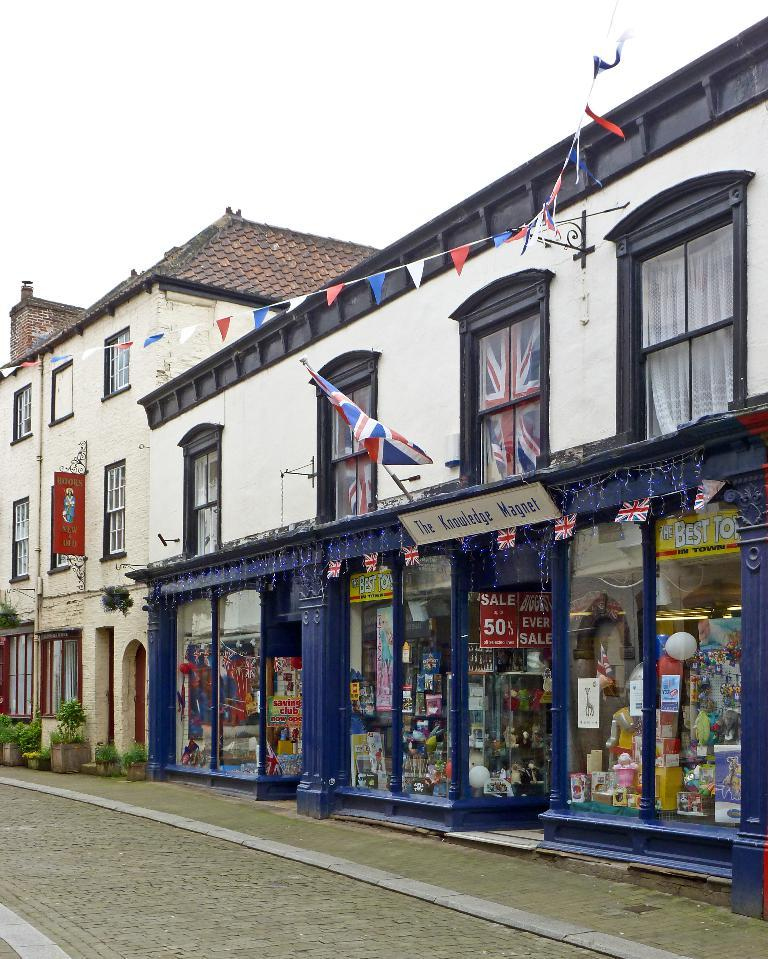What type of structures are located beside the road in the image? There are buildings beside the road in the image. What is one of the buildings used for? One of the buildings houses a store. How can the store be identified in the image? The store has flags displayed. What can be seen inside the store? The store has objects visible. What type of vegetation is present at the bottom left of the image? There are plants at the bottom left of the image. What is visible at the top of the image? The sky is visible at the top of the image. What is the name of the daughter who works at the store in the image? There is no information about a daughter working at the store in the image. How does the light change in the image as time passes? The image is a static representation and does not depict changes in light over time. 